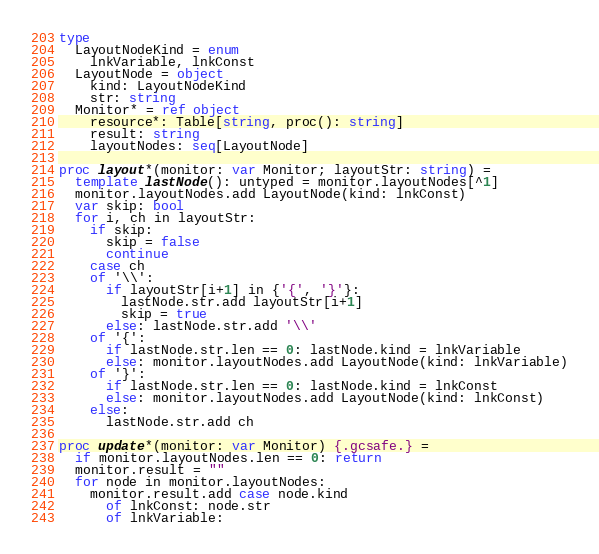Convert code to text. <code><loc_0><loc_0><loc_500><loc_500><_Nim_>
type
  LayoutNodeKind = enum
    lnkVariable, lnkConst
  LayoutNode = object
    kind: LayoutNodeKind
    str: string
  Monitor* = ref object
    resource*: Table[string, proc(): string]
    result: string
    layoutNodes: seq[LayoutNode]

proc layout*(monitor: var Monitor; layoutStr: string) =
  template lastNode(): untyped = monitor.layoutNodes[^1]
  monitor.layoutNodes.add LayoutNode(kind: lnkConst)
  var skip: bool
  for i, ch in layoutStr:
    if skip:
      skip = false
      continue
    case ch
    of '\\':
      if layoutStr[i+1] in {'{', '}'}:
        lastNode.str.add layoutStr[i+1]
        skip = true
      else: lastNode.str.add '\\'
    of '{':
      if lastNode.str.len == 0: lastNode.kind = lnkVariable
      else: monitor.layoutNodes.add LayoutNode(kind: lnkVariable)
    of '}':
      if lastNode.str.len == 0: lastNode.kind = lnkConst
      else: monitor.layoutNodes.add LayoutNode(kind: lnkConst)
    else:
      lastNode.str.add ch

proc update*(monitor: var Monitor) {.gcsafe.} =
  if monitor.layoutNodes.len == 0: return
  monitor.result = ""
  for node in monitor.layoutNodes:
    monitor.result.add case node.kind
      of lnkConst: node.str
      of lnkVariable:</code> 